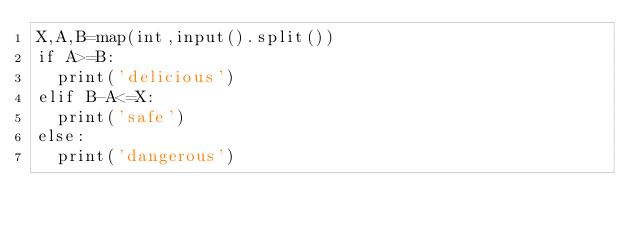<code> <loc_0><loc_0><loc_500><loc_500><_Python_>X,A,B=map(int,input().split())
if A>=B:
  print('delicious')
elif B-A<=X:
  print('safe')
else:
  print('dangerous')
  </code> 